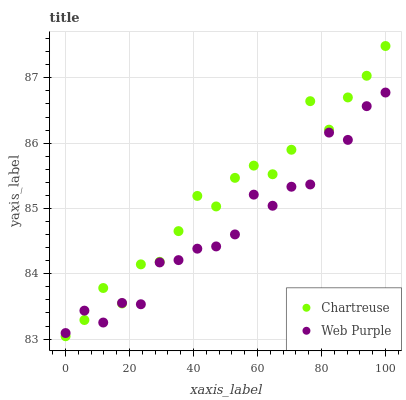Does Web Purple have the minimum area under the curve?
Answer yes or no. Yes. Does Chartreuse have the maximum area under the curve?
Answer yes or no. Yes. Does Web Purple have the maximum area under the curve?
Answer yes or no. No. Is Web Purple the smoothest?
Answer yes or no. Yes. Is Chartreuse the roughest?
Answer yes or no. Yes. Is Web Purple the roughest?
Answer yes or no. No. Does Chartreuse have the lowest value?
Answer yes or no. Yes. Does Web Purple have the lowest value?
Answer yes or no. No. Does Chartreuse have the highest value?
Answer yes or no. Yes. Does Web Purple have the highest value?
Answer yes or no. No. Does Chartreuse intersect Web Purple?
Answer yes or no. Yes. Is Chartreuse less than Web Purple?
Answer yes or no. No. Is Chartreuse greater than Web Purple?
Answer yes or no. No. 